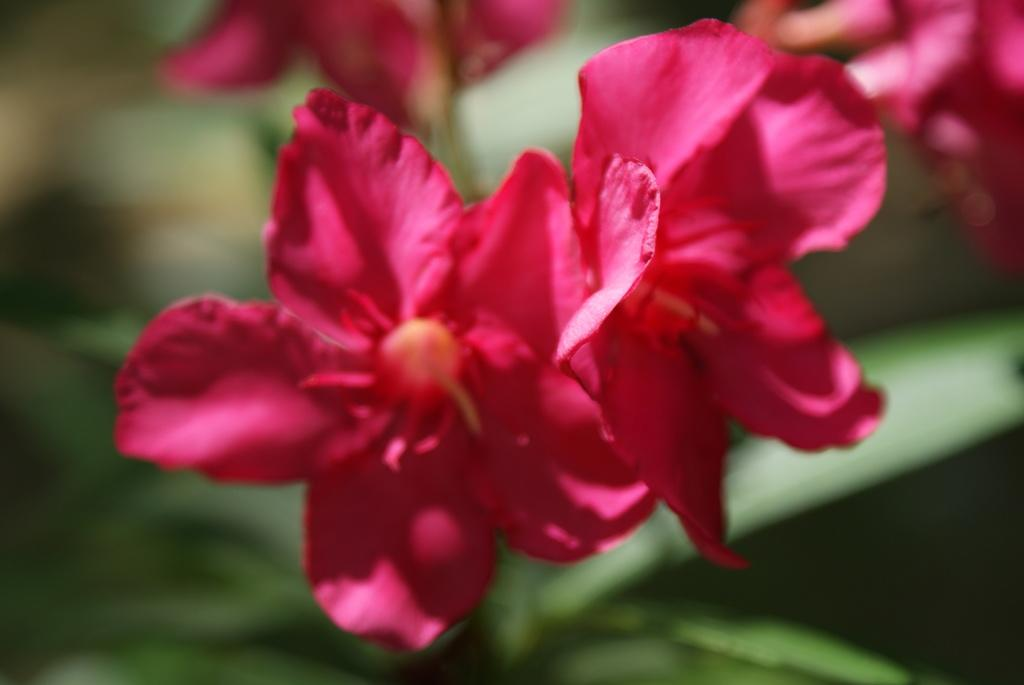How many flowers can be seen in the image? There are two flowers in the image. What can be observed about the background of the image? The background of the image is blurred. What type of metal is the book made of in the image? There is no book or metal present in the image; it only features two flowers. 